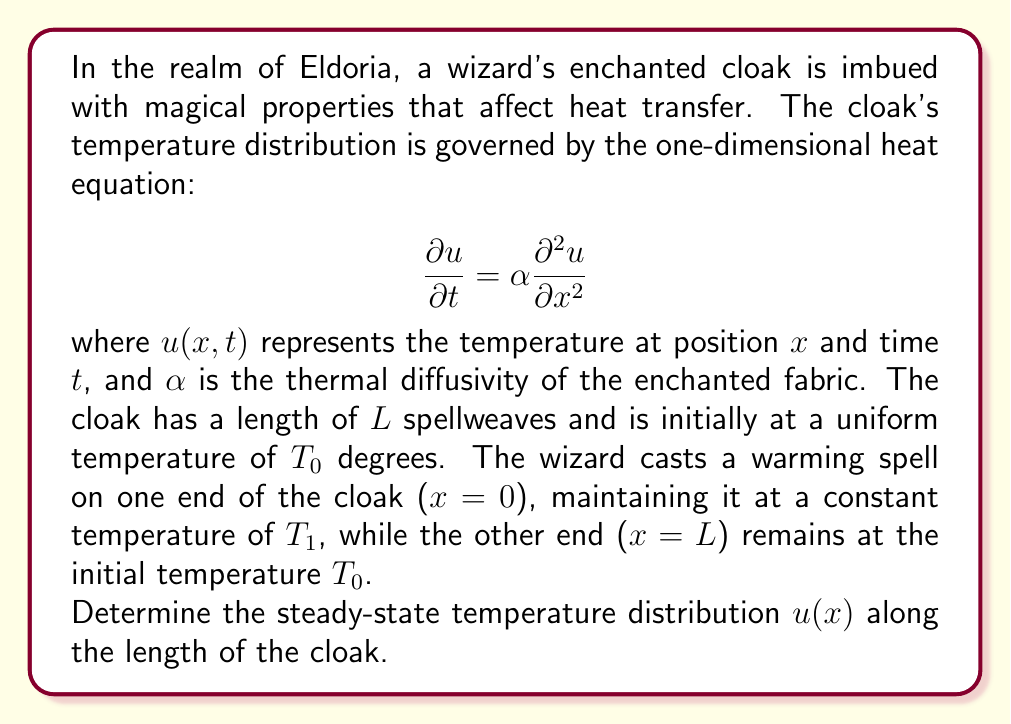Give your solution to this math problem. To solve this problem, we'll follow these steps:

1) For the steady-state solution, the temperature doesn't change with time, so $\frac{\partial u}{\partial t} = 0$. The heat equation reduces to:

   $$ 0 = \alpha \frac{d^2 u}{dx^2} $$

2) Simplifying, we get:

   $$ \frac{d^2 u}{dx^2} = 0 $$

3) Integrating twice:

   $$ \frac{du}{dx} = C_1 $$
   $$ u(x) = C_1x + C_2 $$

   where $C_1$ and $C_2$ are constants to be determined from the boundary conditions.

4) The boundary conditions are:
   - At $x = 0$, $u(0) = T_1$
   - At $x = L$, $u(L) = T_0$

5) Applying these conditions:
   
   $u(0) = C_2 = T_1$
   $u(L) = C_1L + T_1 = T_0$

6) Solving for $C_1$:

   $$ C_1 = \frac{T_0 - T_1}{L} $$

7) Therefore, the steady-state temperature distribution is:

   $$ u(x) = \frac{T_0 - T_1}{L}x + T_1 $$

This linear equation describes how the temperature varies along the length of the cloak, from $T_1$ at $x=0$ to $T_0$ at $x=L$.
Answer: $u(x) = \frac{T_0 - T_1}{L}x + T_1$ 